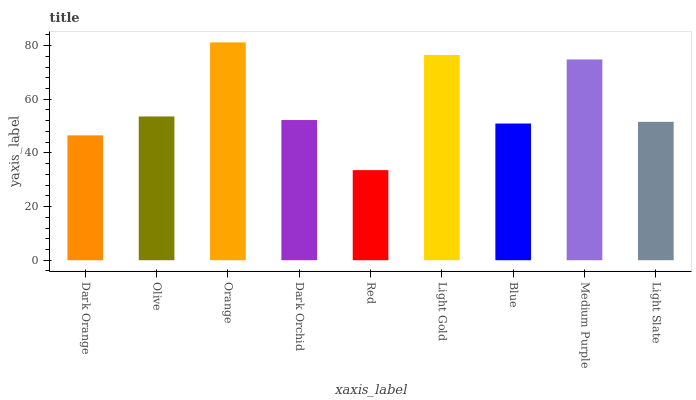Is Red the minimum?
Answer yes or no. Yes. Is Orange the maximum?
Answer yes or no. Yes. Is Olive the minimum?
Answer yes or no. No. Is Olive the maximum?
Answer yes or no. No. Is Olive greater than Dark Orange?
Answer yes or no. Yes. Is Dark Orange less than Olive?
Answer yes or no. Yes. Is Dark Orange greater than Olive?
Answer yes or no. No. Is Olive less than Dark Orange?
Answer yes or no. No. Is Dark Orchid the high median?
Answer yes or no. Yes. Is Dark Orchid the low median?
Answer yes or no. Yes. Is Dark Orange the high median?
Answer yes or no. No. Is Dark Orange the low median?
Answer yes or no. No. 